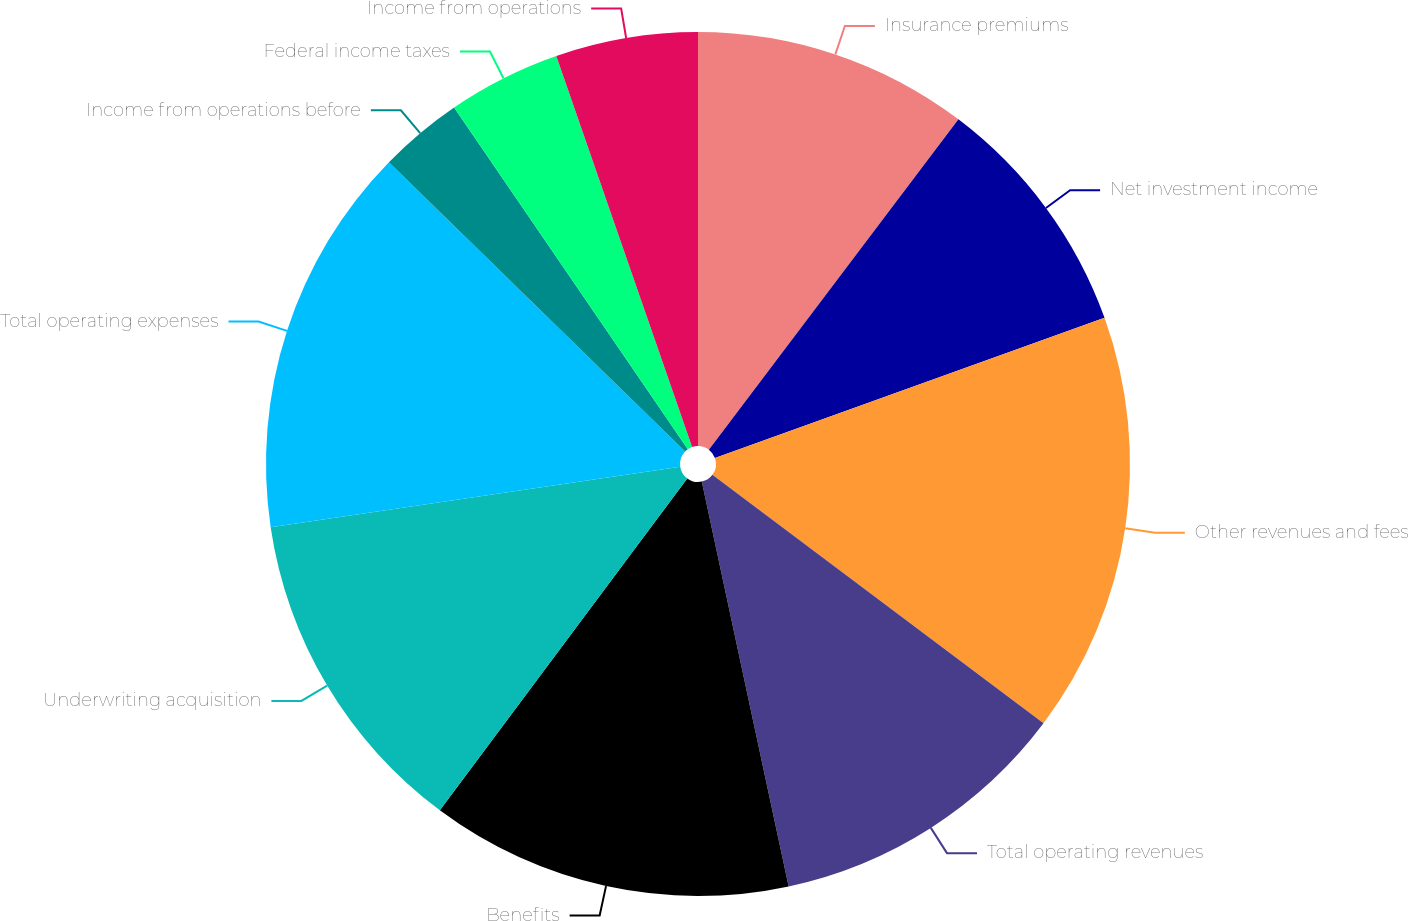<chart> <loc_0><loc_0><loc_500><loc_500><pie_chart><fcel>Insurance premiums<fcel>Net investment income<fcel>Other revenues and fees<fcel>Total operating revenues<fcel>Benefits<fcel>Underwriting acquisition<fcel>Total operating expenses<fcel>Income from operations before<fcel>Federal income taxes<fcel>Income from operations<nl><fcel>10.3%<fcel>9.21%<fcel>15.74%<fcel>11.39%<fcel>13.56%<fcel>12.47%<fcel>14.65%<fcel>3.14%<fcel>4.23%<fcel>5.32%<nl></chart> 